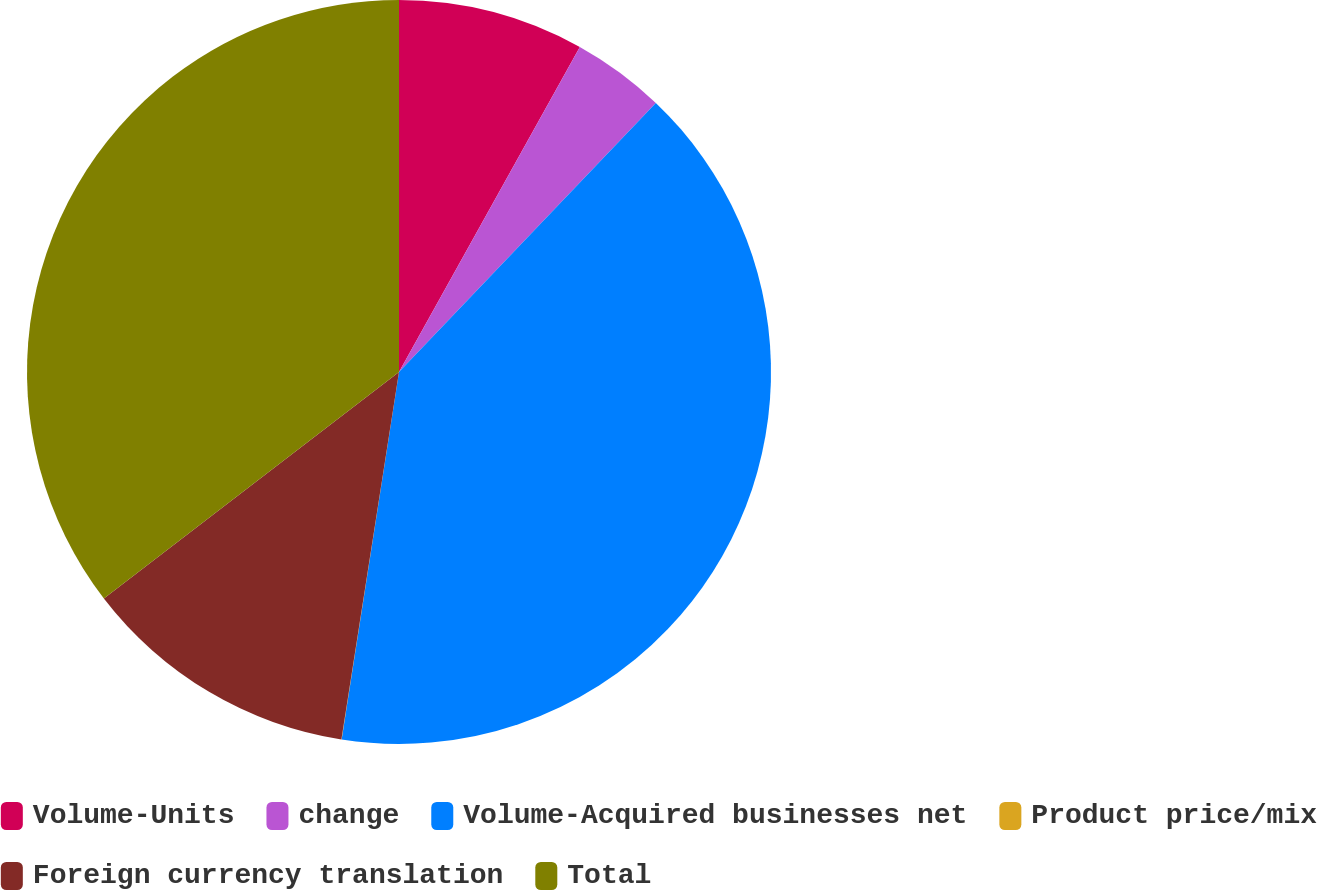Convert chart. <chart><loc_0><loc_0><loc_500><loc_500><pie_chart><fcel>Volume-Units<fcel>change<fcel>Volume-Acquired businesses net<fcel>Product price/mix<fcel>Foreign currency translation<fcel>Total<nl><fcel>8.08%<fcel>4.05%<fcel>40.34%<fcel>0.01%<fcel>12.11%<fcel>35.42%<nl></chart> 